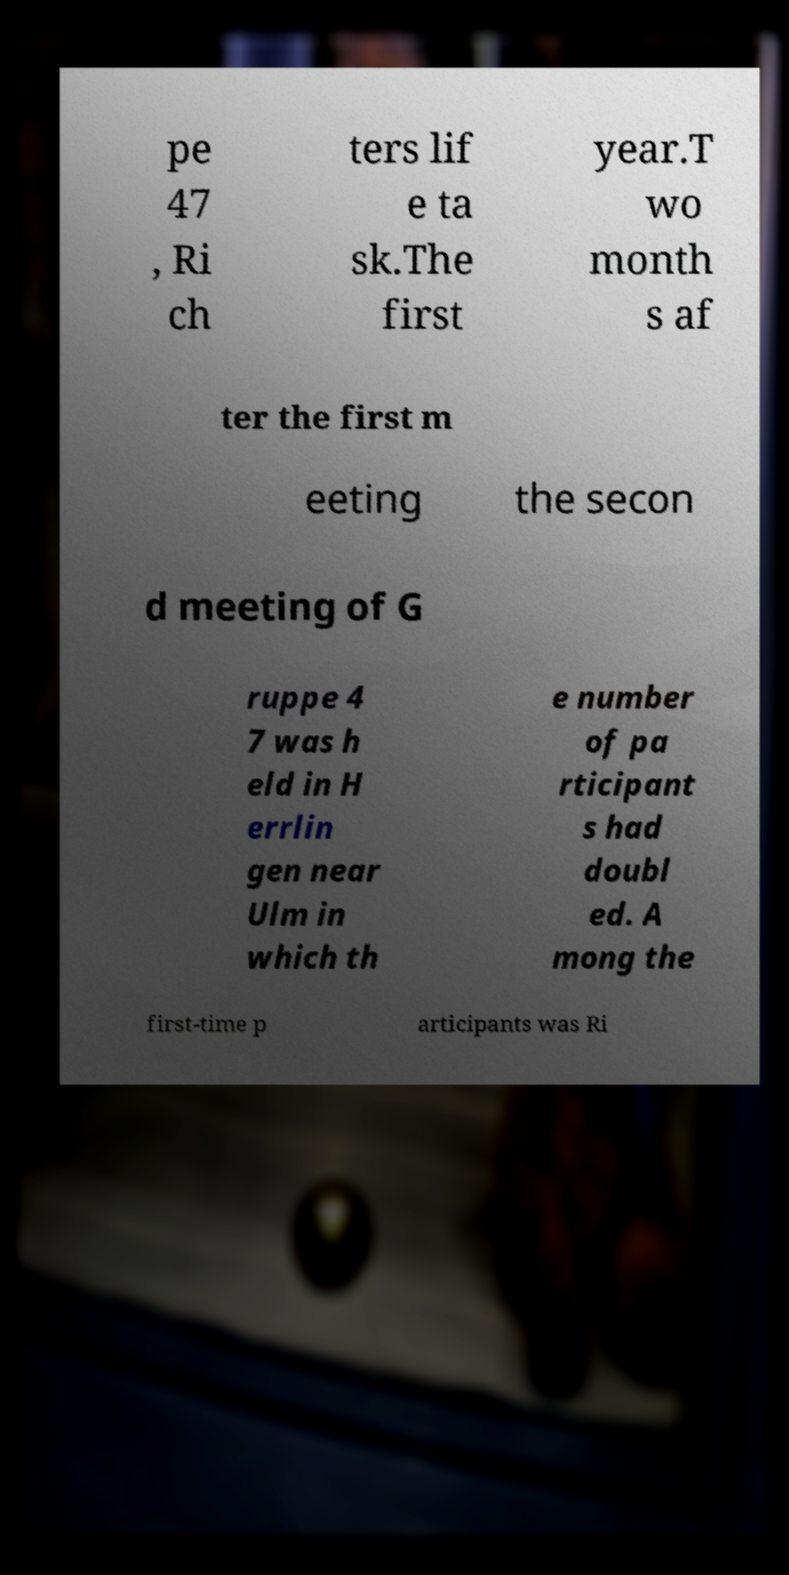Can you accurately transcribe the text from the provided image for me? pe 47 , Ri ch ters lif e ta sk.The first year.T wo month s af ter the first m eeting the secon d meeting of G ruppe 4 7 was h eld in H errlin gen near Ulm in which th e number of pa rticipant s had doubl ed. A mong the first-time p articipants was Ri 